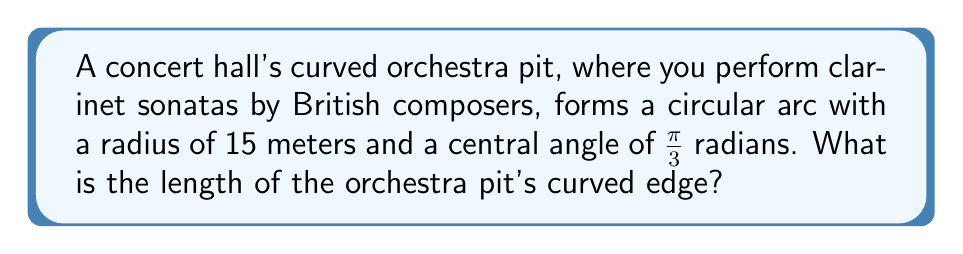Can you solve this math problem? To solve this problem, we'll use the formula for arc length:

$$s = r\theta$$

Where:
$s$ = arc length
$r$ = radius of the circle
$\theta$ = central angle in radians

Given:
$r = 15$ meters
$\theta = \frac{\pi}{3}$ radians

Step 1: Substitute the given values into the formula
$$s = 15 \cdot \frac{\pi}{3}$$

Step 2: Simplify the expression
$$s = 5\pi$$

Step 3: Calculate the final value (rounded to two decimal places)
$$s \approx 15.71\text{ meters}$$

The length of the orchestra pit's curved edge is approximately 15.71 meters.
Answer: $5\pi$ meters or approximately 15.71 meters 